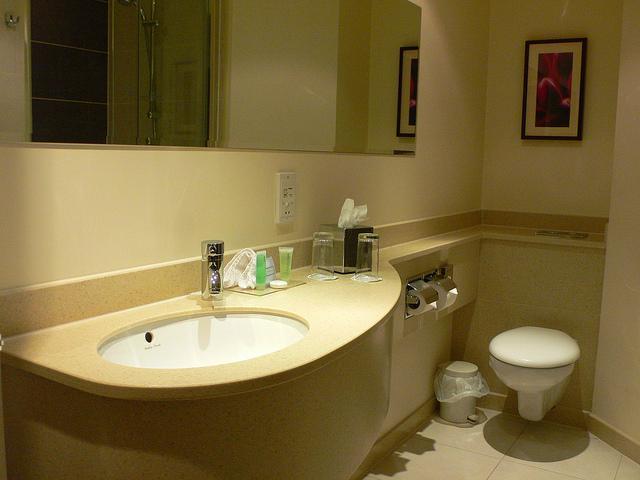How many glasses are there?
Give a very brief answer. 2. How many people are stepping off of a train?
Give a very brief answer. 0. 